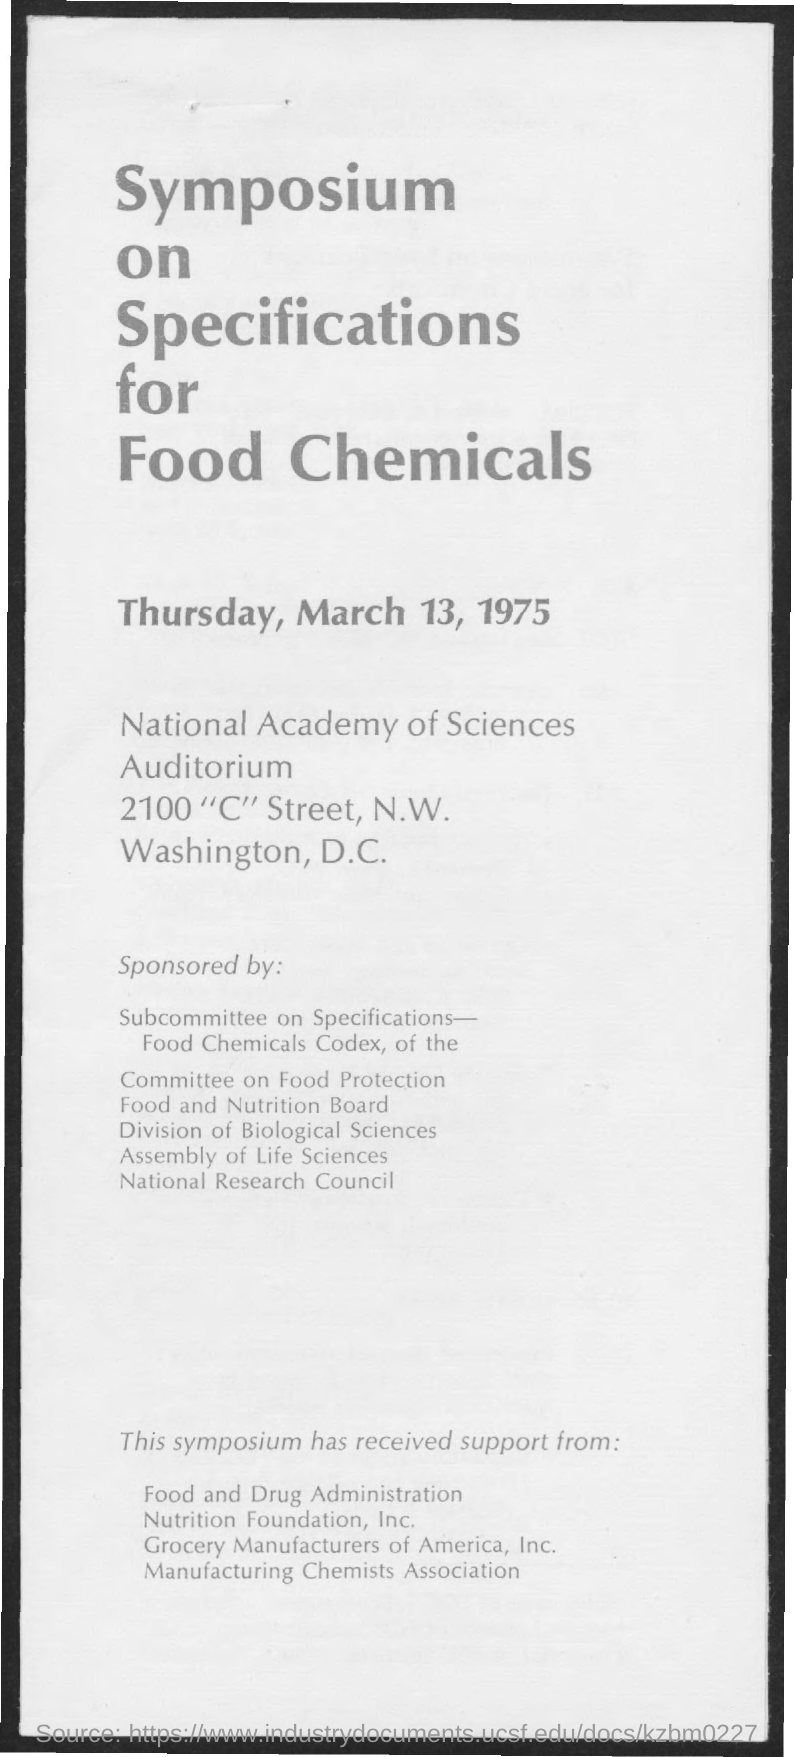Mention a couple of crucial points in this snapshot. On Thursday, March 13, 1975, the Symposium on Specifications for Food Chemicals was held. 